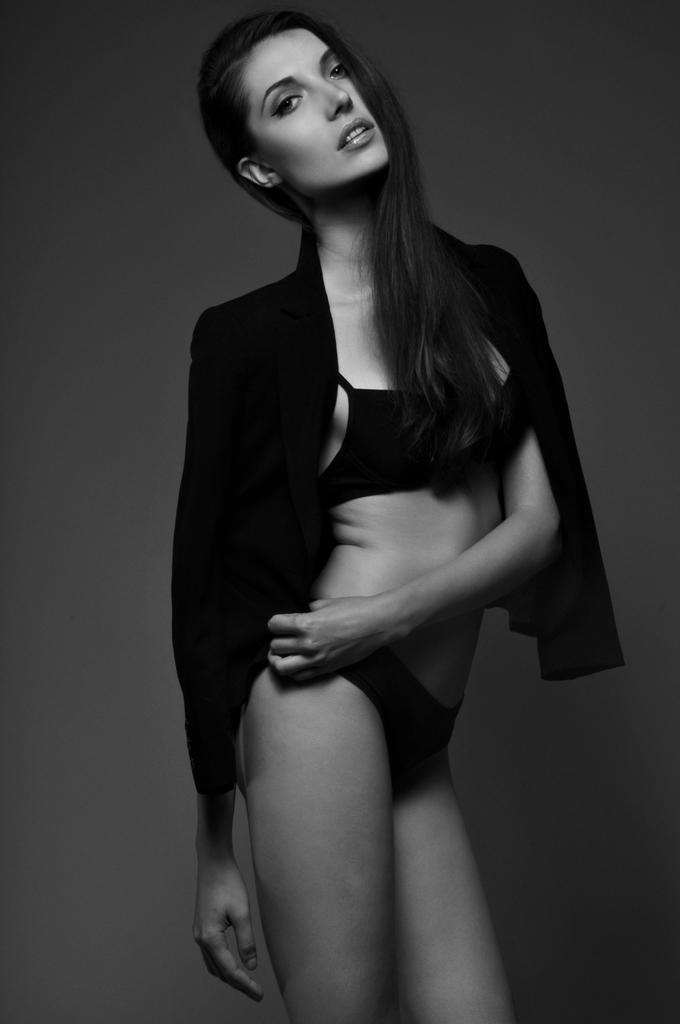Who is the main subject in the picture? There is a woman in the picture. What is the woman doing in the image? The woman is standing in front. What is the woman wearing in the image? The woman is wearing a black dress. What is the color scheme of the image? The image is black and white. How many men are present in the image? There are no men present in the image; it features a woman. What type of snake can be seen slithering on the woman's dress in the image? There is no snake present in the image; the woman is wearing a black dress. 